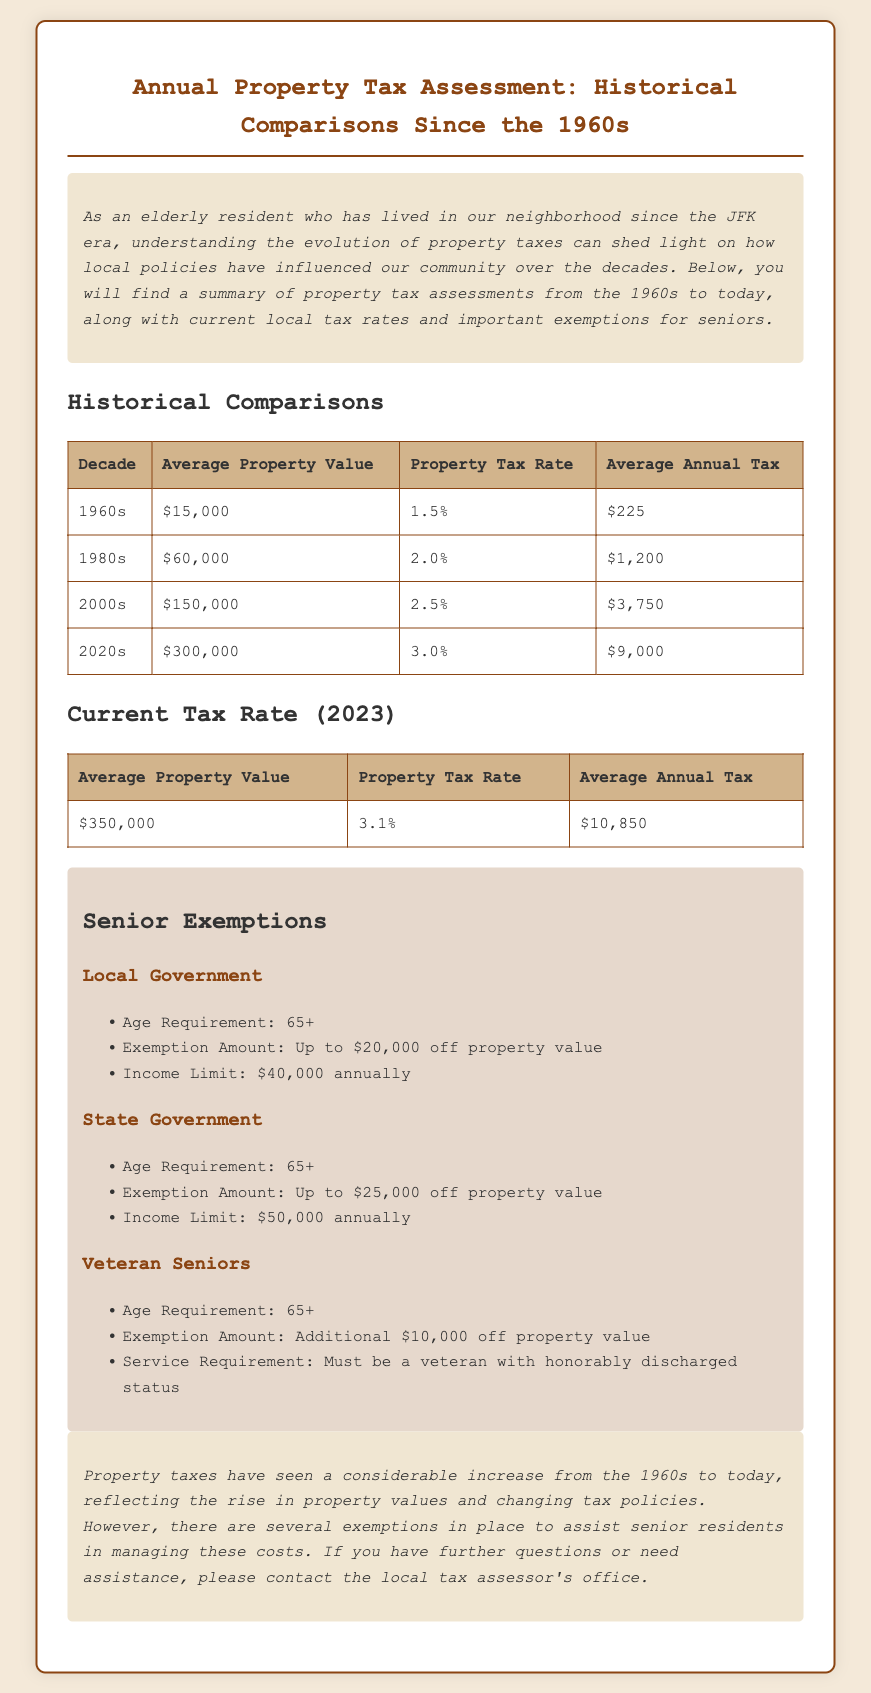What was the average property value in the 1960s? The average property value is presented in the historical comparisons table, which lists it as $15,000 for the 1960s.
Answer: $15,000 What is the current property tax rate in 2023? The current property tax rate for 2023 is provided in the table under "Current Tax Rate," which states it is 3.1%.
Answer: 3.1% What was the average annual tax in the 1980s? The average annual tax for the 1980s is mentioned in the historical comparisons table, where it is listed as $1,200.
Answer: $1,200 What is the exemption amount for local government seniors? The exemption amount for local government seniors is detailed in the senior exemptions section, specifying it as up to $20,000 off property value.
Answer: Up to $20,000 What property value amount do veteran seniors receive in additional exemptions? The additional exemption amount for veteran seniors is highlighted in the exemptions section, stating it is an additional $10,000 off property value.
Answer: $10,000 What was the average annual tax in the 2020s? The average annual tax for the 2020s is indicated in the historical comparisons table, showing it as $9,000.
Answer: $9,000 What is the income limit for local government exemptions? The income limit for local government exemptions is stated in the exemptions section as $40,000 annually.
Answer: $40,000 Which decade had the highest property tax rate? The highest property tax rate is mentioned in the historical comparisons, with the 2020s showing a rate of 3.0%, making it the highest among listed decades.
Answer: 2020s What is the age requirement for state government exemptions? The age requirement for state government exemptions is noted in the exemptions section as 65+.
Answer: 65+ 